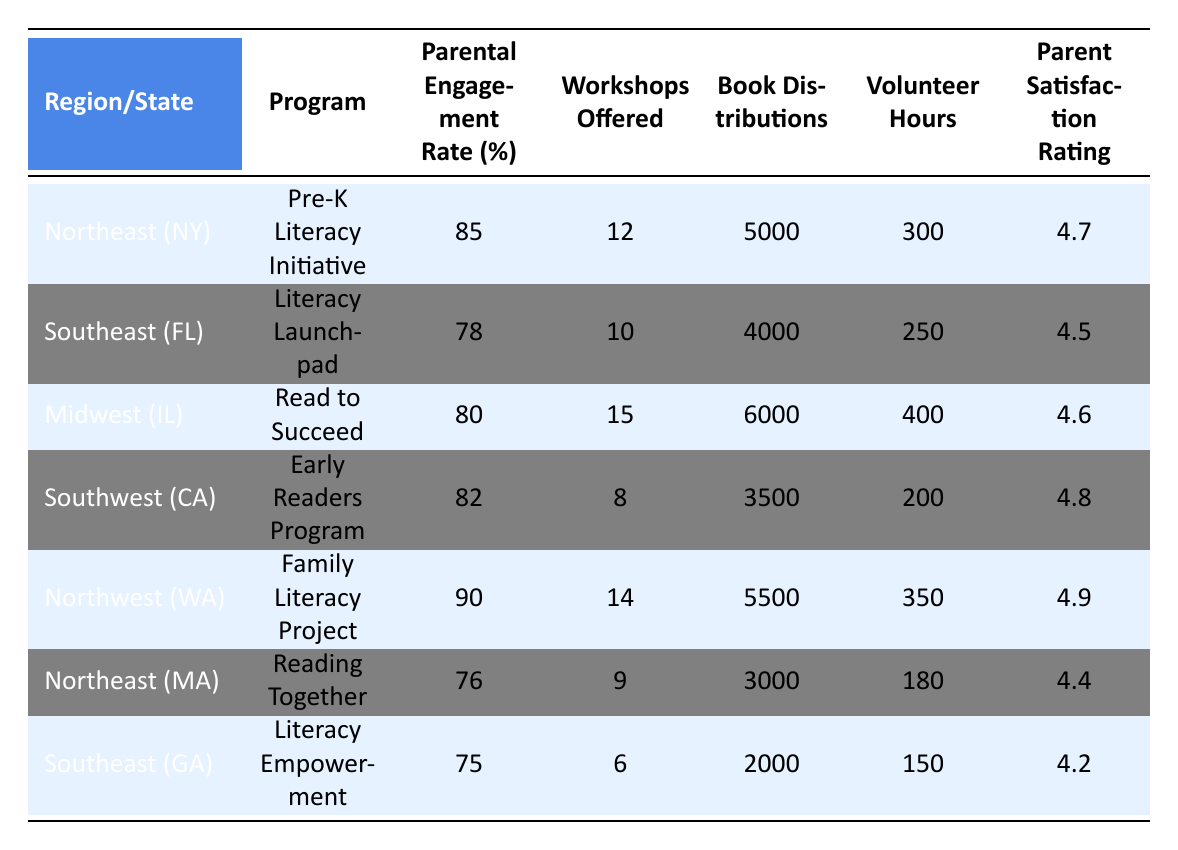What is the Parental Engagement Rate for the Family Literacy Project in Washington? The table shows that the Parental Engagement Rate for the Family Literacy Project in Washington (Northwest region) is 90%.
Answer: 90% Which program has the highest Parent Satisfaction Rating? Looking at the Parent Satisfaction Ratings in the table, the Family Literacy Project has the highest rating of 4.9.
Answer: Family Literacy Project What is the difference in Volunteer Hours between the Pre-K Literacy Initiative and the Literacy Launchpad? The table states that the Pre-K Literacy Initiative has 300 Volunteer Hours and the Literacy Launchpad has 250 Volunteer Hours. The difference is 300 - 250 = 50 hours.
Answer: 50 hours How many Workshops were offered in total across all programs? By summing the Workshops Offered from all programs: 12 + 10 + 15 + 8 + 14 + 9 + 6 = 74.
Answer: 74 True or False: The Literacy Empowerment program offered more Workshops than the Early Readers Program. The Literacy Empowerment program offered 6 Workshops, while the Early Readers Program offered 8 Workshops. Therefore, it is false that Literacy Empowerment offered more.
Answer: False What is the average Parental Engagement Rate across all regions? To find the average, sum all the Engagement Rates (85 + 78 + 80 + 82 + 90 + 76 + 75 = 566) and divide by the number of programs (7), which is 566 / 7 = 80.86.
Answer: 80.86 Which region has the lowest Book Distributions, and what is that amount? The Literacy Empowerment program in Georgia has the lowest Book Distributions, with a total of 2000 books distributed.
Answer: 2000 books How many more Workshops were offered in the Midwest compared to the Southeast? The Read to Succeed program in the Midwest offered 15 Workshops, while the Literacy Launchpad in the Southeast offered 10 Workshops. The difference is 15 - 10 = 5 Workshops.
Answer: 5 Workshops What is the total number of Book Distributions from all programs? Adding the Book Distributions from each program gives: 5000 + 4000 + 6000 + 3500 + 5500 + 3000 + 2000 = 29000.
Answer: 29000 Is the Parental Engagement Rate of the Reading Together program higher than 80%? The Reading Together program has a Parental Engagement Rate of 76%, which is not higher than 80%. Therefore, the answer is no.
Answer: No How do the Volunteer Hours of the Family Literacy Project compare to those of the Early Readers Program? The Family Literacy Project has 350 Volunteer Hours, while the Early Readers Program has 200. The Family Literacy Project offers 150 more Volunteer Hours than the Early Readers Program.
Answer: 150 more Volunteer Hours 